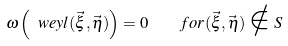Convert formula to latex. <formula><loc_0><loc_0><loc_500><loc_500>\omega \left ( \ w e y l ( \vec { \xi } , \vec { \eta } ) \right ) = 0 \quad f o r ( \vec { \xi } , \vec { \eta } ) \notin S \,</formula> 